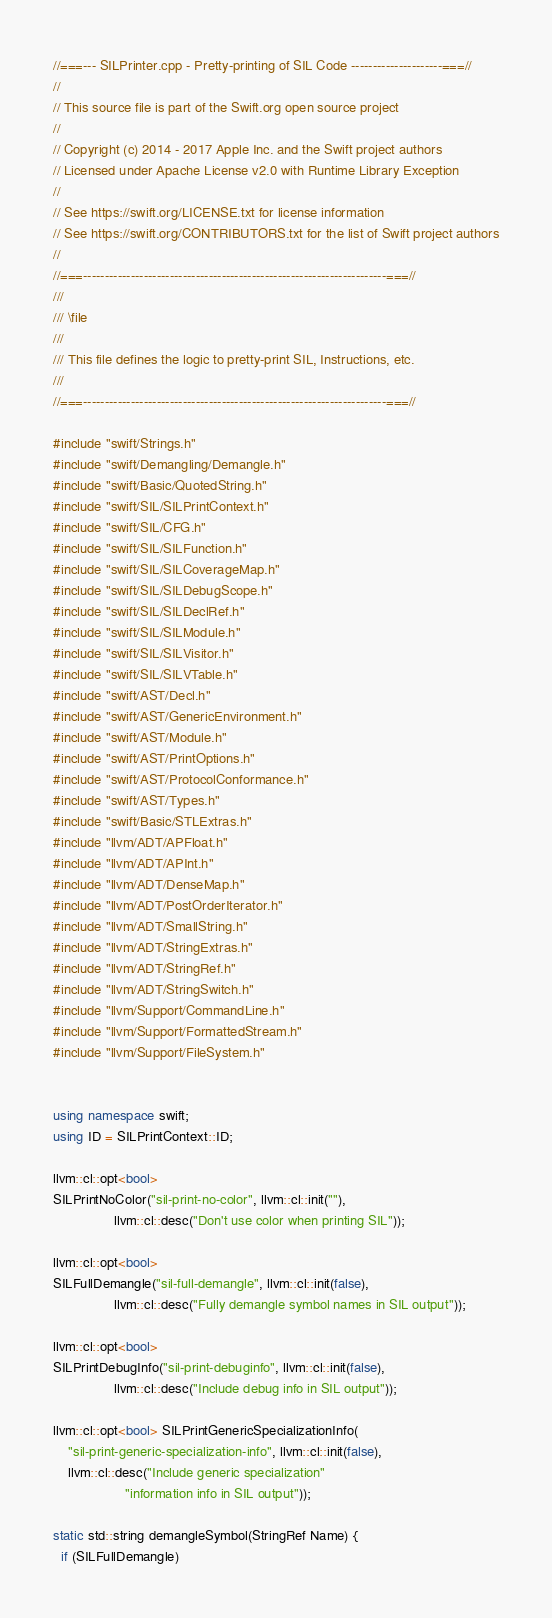<code> <loc_0><loc_0><loc_500><loc_500><_C++_>//===--- SILPrinter.cpp - Pretty-printing of SIL Code ---------------------===//
//
// This source file is part of the Swift.org open source project
//
// Copyright (c) 2014 - 2017 Apple Inc. and the Swift project authors
// Licensed under Apache License v2.0 with Runtime Library Exception
//
// See https://swift.org/LICENSE.txt for license information
// See https://swift.org/CONTRIBUTORS.txt for the list of Swift project authors
//
//===----------------------------------------------------------------------===//
///
/// \file
///
/// This file defines the logic to pretty-print SIL, Instructions, etc.
///
//===----------------------------------------------------------------------===//

#include "swift/Strings.h"
#include "swift/Demangling/Demangle.h"
#include "swift/Basic/QuotedString.h"
#include "swift/SIL/SILPrintContext.h"
#include "swift/SIL/CFG.h"
#include "swift/SIL/SILFunction.h"
#include "swift/SIL/SILCoverageMap.h"
#include "swift/SIL/SILDebugScope.h"
#include "swift/SIL/SILDeclRef.h"
#include "swift/SIL/SILModule.h"
#include "swift/SIL/SILVisitor.h"
#include "swift/SIL/SILVTable.h"
#include "swift/AST/Decl.h"
#include "swift/AST/GenericEnvironment.h"
#include "swift/AST/Module.h"
#include "swift/AST/PrintOptions.h"
#include "swift/AST/ProtocolConformance.h"
#include "swift/AST/Types.h"
#include "swift/Basic/STLExtras.h"
#include "llvm/ADT/APFloat.h"
#include "llvm/ADT/APInt.h"
#include "llvm/ADT/DenseMap.h"
#include "llvm/ADT/PostOrderIterator.h"
#include "llvm/ADT/SmallString.h"
#include "llvm/ADT/StringExtras.h"
#include "llvm/ADT/StringRef.h"
#include "llvm/ADT/StringSwitch.h"
#include "llvm/Support/CommandLine.h"
#include "llvm/Support/FormattedStream.h"
#include "llvm/Support/FileSystem.h"


using namespace swift;
using ID = SILPrintContext::ID;

llvm::cl::opt<bool>
SILPrintNoColor("sil-print-no-color", llvm::cl::init(""),
                llvm::cl::desc("Don't use color when printing SIL"));

llvm::cl::opt<bool>
SILFullDemangle("sil-full-demangle", llvm::cl::init(false),
                llvm::cl::desc("Fully demangle symbol names in SIL output"));

llvm::cl::opt<bool>
SILPrintDebugInfo("sil-print-debuginfo", llvm::cl::init(false),
                llvm::cl::desc("Include debug info in SIL output"));

llvm::cl::opt<bool> SILPrintGenericSpecializationInfo(
    "sil-print-generic-specialization-info", llvm::cl::init(false),
    llvm::cl::desc("Include generic specialization"
                   "information info in SIL output"));

static std::string demangleSymbol(StringRef Name) {
  if (SILFullDemangle)</code> 